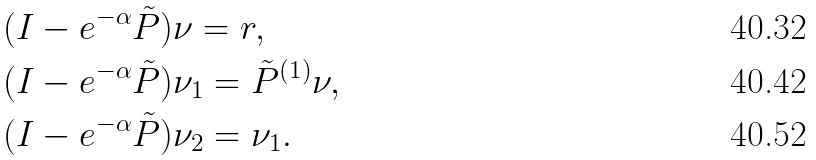<formula> <loc_0><loc_0><loc_500><loc_500>& ( I - e ^ { - \alpha } \tilde { P } ) \nu = r , \\ & ( I - e ^ { - \alpha } \tilde { P } ) \nu _ { 1 } = \tilde { P } ^ { ( 1 ) } \nu , \\ & ( I - e ^ { - \alpha } \tilde { P } ) \nu _ { 2 } = \nu _ { 1 } .</formula> 